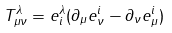<formula> <loc_0><loc_0><loc_500><loc_500>T ^ { \lambda } _ { \mu \nu } = e ^ { \lambda } _ { i } ( \partial _ { \mu } e ^ { i } _ { \nu } - \partial _ { \nu } e ^ { i } _ { \mu } )</formula> 